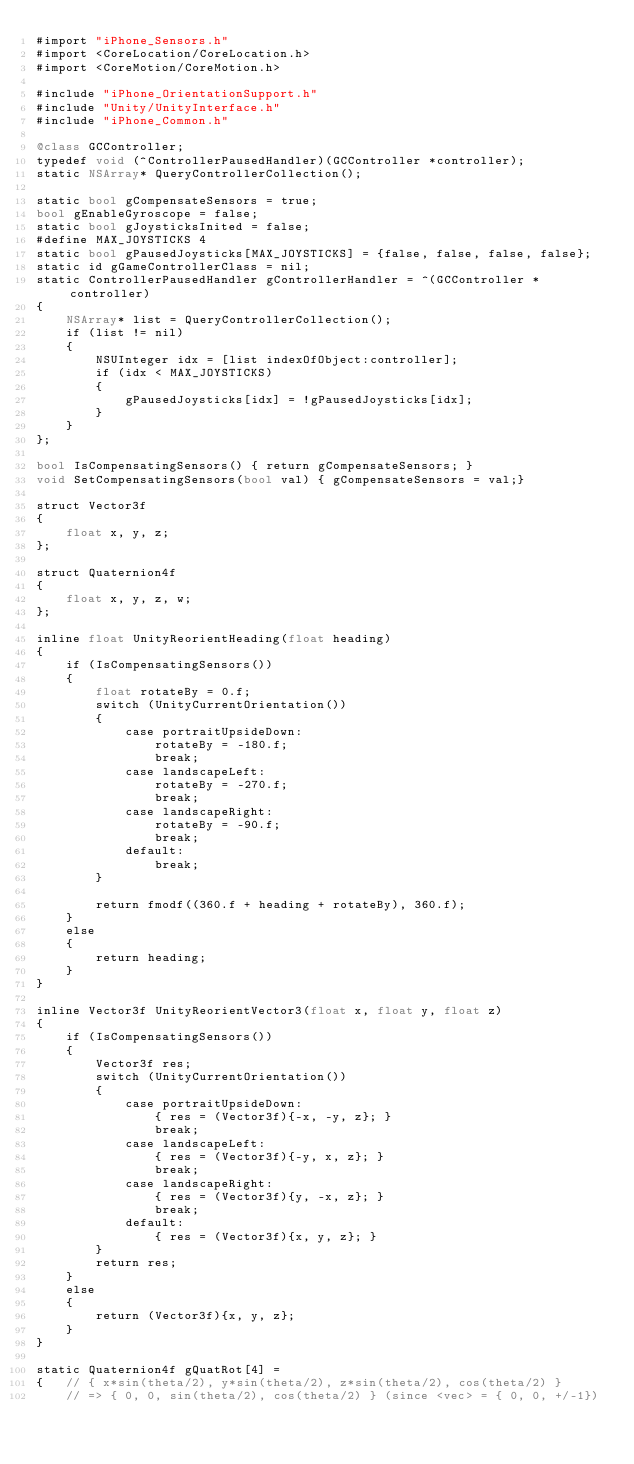Convert code to text. <code><loc_0><loc_0><loc_500><loc_500><_ObjectiveC_>#import "iPhone_Sensors.h"
#import <CoreLocation/CoreLocation.h>
#import <CoreMotion/CoreMotion.h>

#include "iPhone_OrientationSupport.h"
#include "Unity/UnityInterface.h"
#include "iPhone_Common.h"

@class GCController;
typedef void (^ControllerPausedHandler)(GCController *controller);
static NSArray* QueryControllerCollection();

static bool gCompensateSensors = true;
bool gEnableGyroscope = false;
static bool gJoysticksInited = false;
#define MAX_JOYSTICKS 4
static bool gPausedJoysticks[MAX_JOYSTICKS] = {false, false, false, false};
static id gGameControllerClass = nil;
static ControllerPausedHandler gControllerHandler = ^(GCController *controller) 
{
	NSArray* list = QueryControllerCollection();
	if (list != nil)
	{
		NSUInteger idx = [list indexOfObject:controller];
		if (idx < MAX_JOYSTICKS)
		{
			gPausedJoysticks[idx] = !gPausedJoysticks[idx];
		}
	}
};

bool IsCompensatingSensors() { return gCompensateSensors; }
void SetCompensatingSensors(bool val) { gCompensateSensors = val;}

struct Vector3f
{
	float x, y, z;
};

struct Quaternion4f
{
	float x, y, z, w;
};

inline float UnityReorientHeading(float heading)
{
	if (IsCompensatingSensors())
	{
		float rotateBy = 0.f;
		switch (UnityCurrentOrientation())
		{
			case portraitUpsideDown:
				rotateBy = -180.f;
				break;
			case landscapeLeft:
				rotateBy = -270.f;
				break;
			case landscapeRight:
				rotateBy = -90.f;
				break;
			default:
				break;
		}

		return fmodf((360.f + heading + rotateBy), 360.f);
	}
	else
	{
		return heading;
	}
}

inline Vector3f UnityReorientVector3(float x, float y, float z)
{
	if (IsCompensatingSensors())
	{
		Vector3f res;
		switch (UnityCurrentOrientation())
		{
			case portraitUpsideDown:
				{ res = (Vector3f){-x, -y, z}; }
				break;
			case landscapeLeft:
				{ res = (Vector3f){-y, x, z}; }
				break;
			case landscapeRight:
				{ res = (Vector3f){y, -x, z}; }
				break;
			default:
				{ res = (Vector3f){x, y, z}; }
		}
		return res;
	}
	else
	{
		return (Vector3f){x, y, z};
	}
}

static Quaternion4f gQuatRot[4] =
{	// { x*sin(theta/2), y*sin(theta/2), z*sin(theta/2), cos(theta/2) }
	// => { 0, 0, sin(theta/2), cos(theta/2) } (since <vec> = { 0, 0, +/-1})</code> 